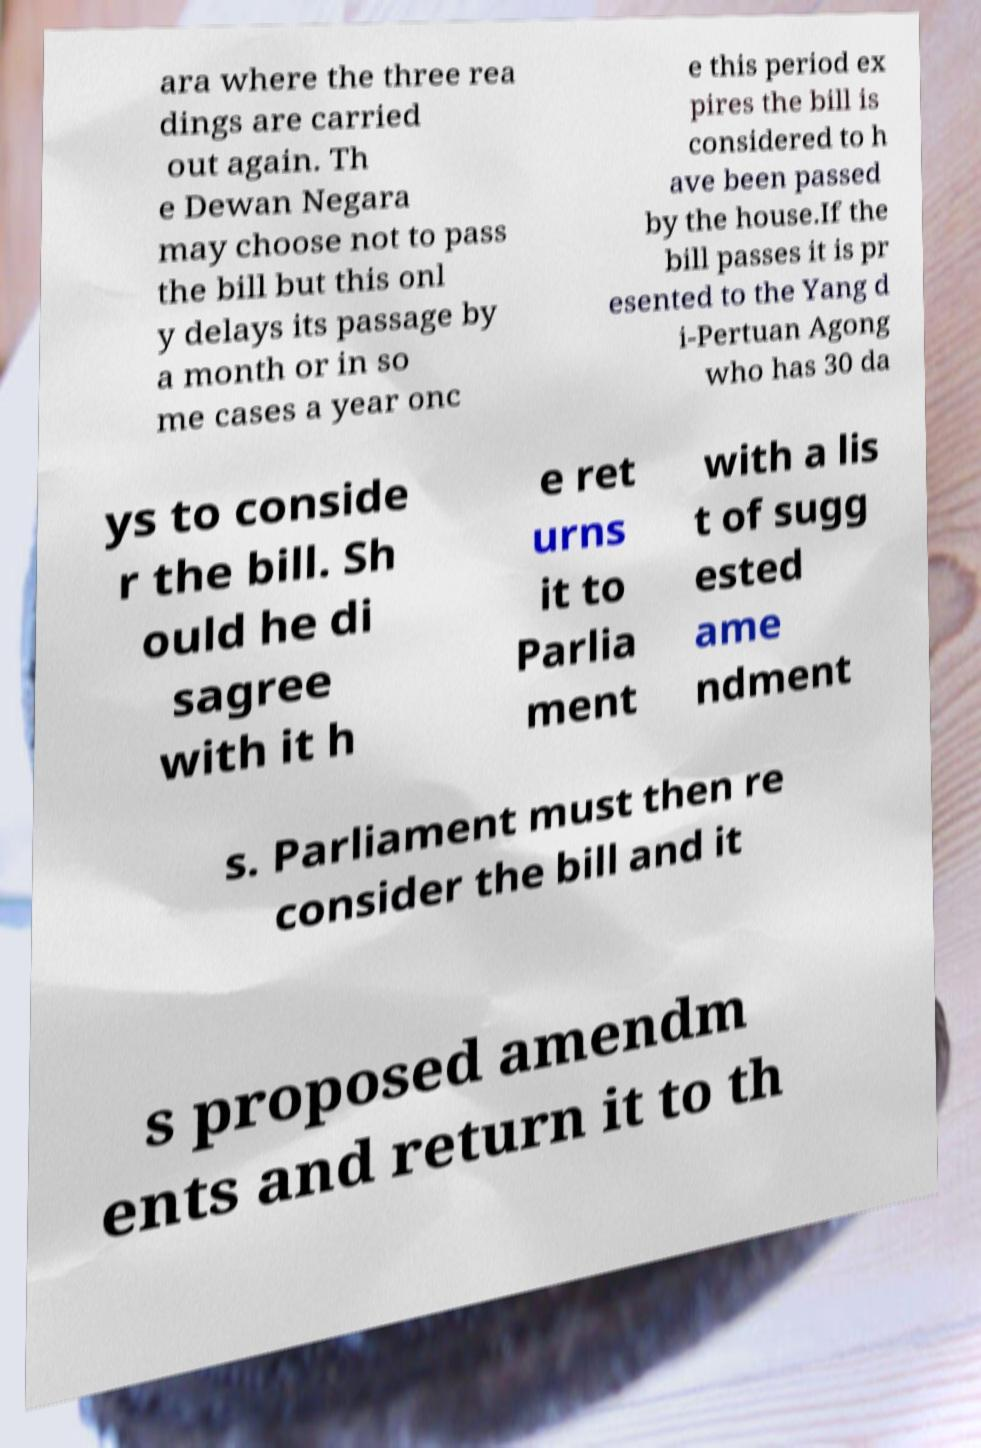Can you accurately transcribe the text from the provided image for me? ara where the three rea dings are carried out again. Th e Dewan Negara may choose not to pass the bill but this onl y delays its passage by a month or in so me cases a year onc e this period ex pires the bill is considered to h ave been passed by the house.If the bill passes it is pr esented to the Yang d i-Pertuan Agong who has 30 da ys to conside r the bill. Sh ould he di sagree with it h e ret urns it to Parlia ment with a lis t of sugg ested ame ndment s. Parliament must then re consider the bill and it s proposed amendm ents and return it to th 